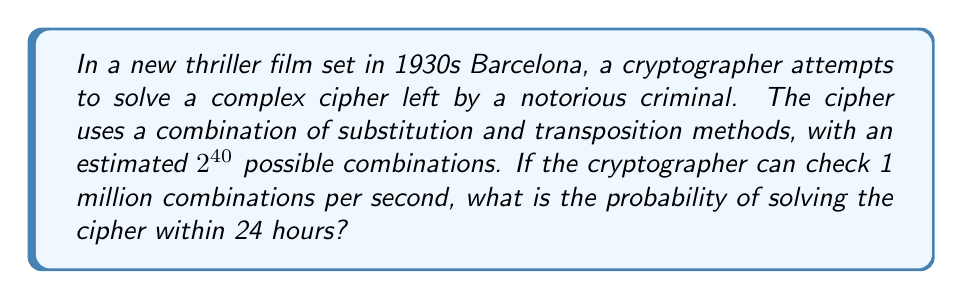Show me your answer to this math problem. Let's approach this step-by-step:

1) First, we need to calculate how many combinations can be checked in 24 hours:
   
   $$ \text{Combinations per second} = 1,000,000 $$
   $$ \text{Seconds in 24 hours} = 24 \times 60 \times 60 = 86,400 $$
   $$ \text{Total combinations checked} = 1,000,000 \times 86,400 = 86,400,000,000 $$

2) Now, we know the total number of possible combinations:
   
   $$ \text{Total possible combinations} = 2^{40} = 1,099,511,627,776 $$

3) The probability of solving the cipher is equal to the number of combinations checked divided by the total number of possible combinations:

   $$ P(\text{solving}) = \frac{\text{Combinations checked}}{\text{Total possible combinations}} $$

4) Substituting our values:

   $$ P(\text{solving}) = \frac{86,400,000,000}{1,099,511,627,776} \approx 0.0786 $$

5) Converting to a percentage:

   $$ P(\text{solving}) \approx 7.86\% $$
Answer: $7.86\%$ 